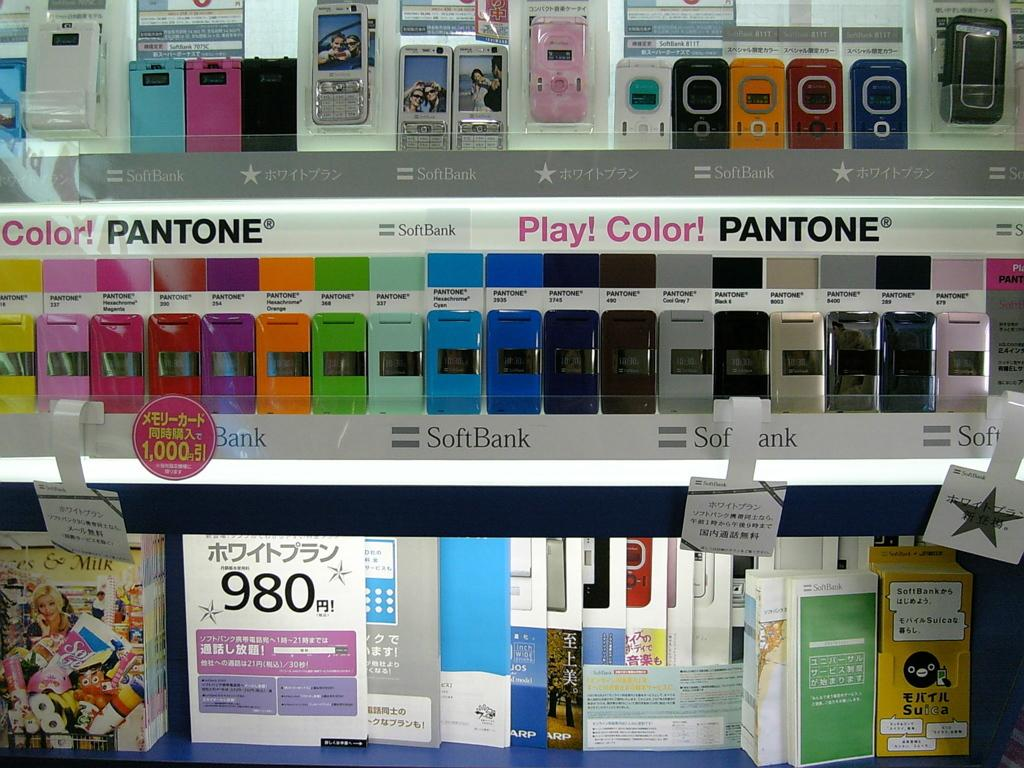<image>
Relay a brief, clear account of the picture shown. a colorful display of Play! Color! Pantone cell phones by Soft Bank 